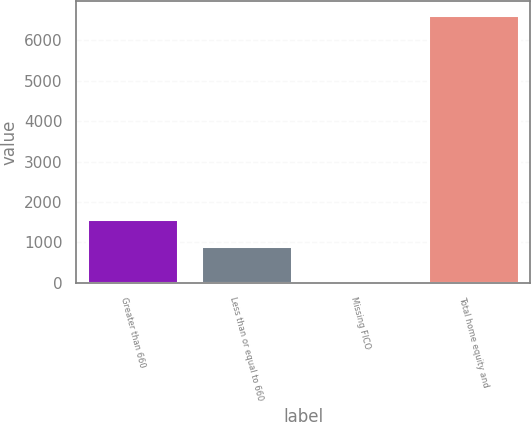Convert chart. <chart><loc_0><loc_0><loc_500><loc_500><bar_chart><fcel>Greater than 660<fcel>Less than or equal to 660<fcel>Missing FICO<fcel>Total home equity and<nl><fcel>1578.9<fcel>920<fcel>49<fcel>6638<nl></chart> 